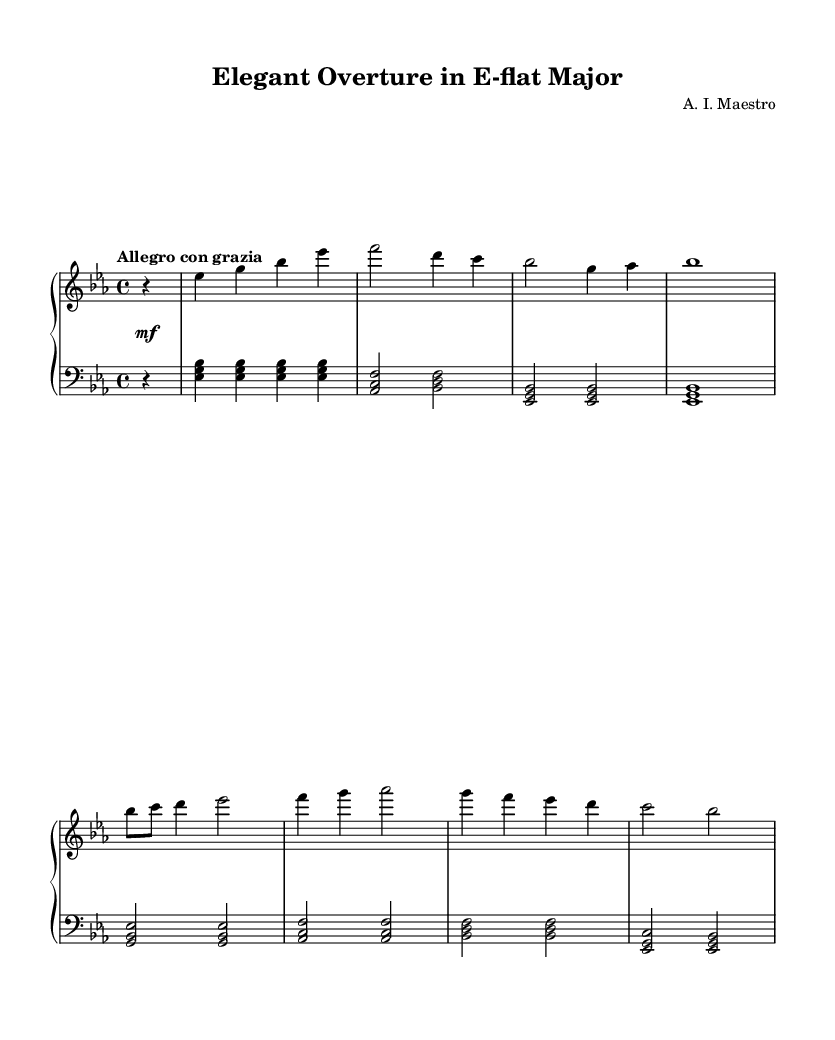What is the key signature of this music? The key signature features three flats, which are B-flat, E-flat, and A-flat, indicating that the piece is in E-flat major.
Answer: E-flat major What is the time signature of this piece? The time signature is located at the beginning of the staff and indicates the number of beats in a measure, which is 4 beats per measure.
Answer: 4/4 What tempo marking is indicated above the staff? The tempo marking is shown at the start of the score, indicating the desired speed or mood of the piece, which is "Allegro con grazia."
Answer: Allegro con grazia How many measures does the left hand have in this section? By counting the measures indicated in the left-hand staff, we can establish that there are eight distinct measures present in this section of music.
Answer: Eight What is the dynamic marking for the first half of the piece? The dynamic marking at the beginning indicates a mezzo-forte level, which guides performers to play at a moderately loud volume during this section.
Answer: Mezzo-forte In which measure does the right hand first play a whole note? Observing the right-hand staff reveals that the first whole note played appears in the fourth measure, where the last note is a whole note.
Answer: Fourth measure What is the highest note played in the right hand? Analyzing the right hand part, the highest note is G, which appears in the fifth bar of the score.
Answer: G 